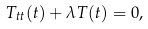<formula> <loc_0><loc_0><loc_500><loc_500>T _ { t t } ( t ) + \lambda T ( t ) = 0 ,</formula> 